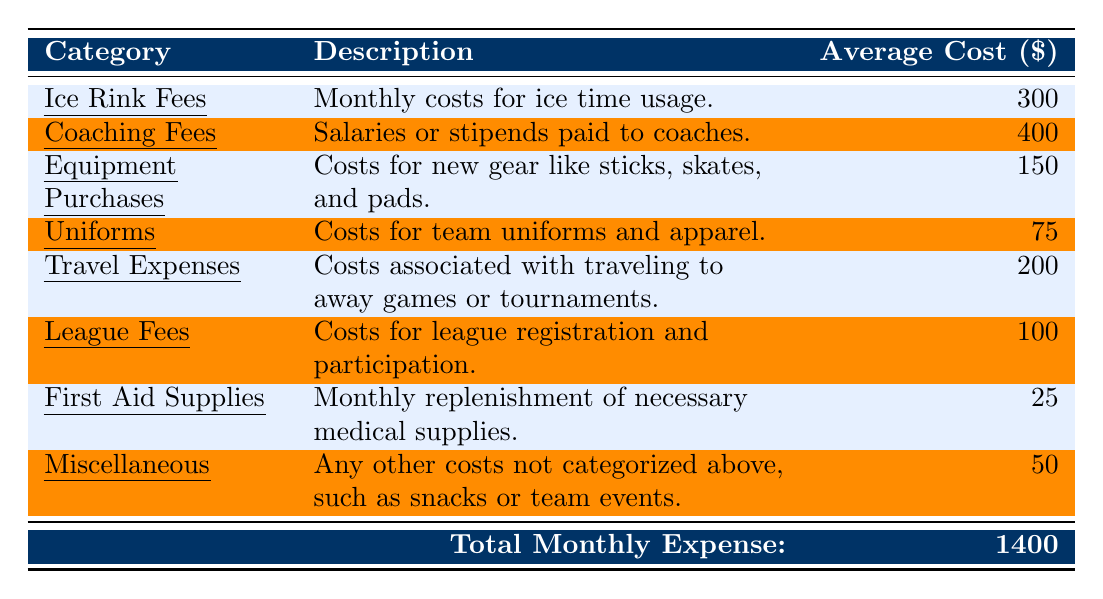What is the average cost for Ice Rink Fees? The table lists the average cost for Ice Rink Fees as 300 dollars.
Answer: 300 What is the total monthly expense for youth sports programs? The table indicates that the total monthly expense is 1400 dollars.
Answer: 1400 How much are Coaching Fees on average compared to Equipment Purchases? Coaching Fees average 400 dollars, while Equipment Purchases average 150 dollars. The difference is 400 - 150 = 250 dollars.
Answer: 250 Are First Aid Supplies the least expensive category? The average cost of First Aid Supplies is 25 dollars, which is lower than all other categories listed in the table.
Answer: Yes What is the total for Travel Expenses and League Fees combined? Travel Expenses are 200 dollars and League Fees are 100 dollars. Adding these together gives 200 + 100 = 300 dollars.
Answer: 300 What is the average cost of the four categories: Equipment Purchases, Uniforms, Travel Expenses, and Miscellaneous? Their average cost is calculated as (150 + 75 + 200 + 50) / 4 = 475 / 4 = 118.75 dollars.
Answer: 118.75 What percentage of the total monthly expense does Coaching Fees represent? To find the percentage: (Coaching Fees / Total Monthly Expense) x 100 = (400 / 1400) x 100 ≈ 28.57%.
Answer: 28.57% If all categories except for Miscellaneous were eliminated, what would be the new total monthly expense? The total of all categories except Miscellaneous (1400 - 50) results in 1350 dollars.
Answer: 1350 Which category has the highest average cost? Coaching Fees, at 400 dollars, is the highest average cost category listed in the table.
Answer: Coaching Fees How much less do Uniforms cost compared to Ice Rink Fees? The difference between Ice Rink Fees (300 dollars) and Uniforms (75 dollars) is calculated as 300 - 75 = 225 dollars.
Answer: 225 What is the total cost of First Aid Supplies and Miscellaneous expenses? First Aid Supplies cost 25 dollars and Miscellaneous costs 50 dollars, totaling 25 + 50 = 75 dollars.
Answer: 75 